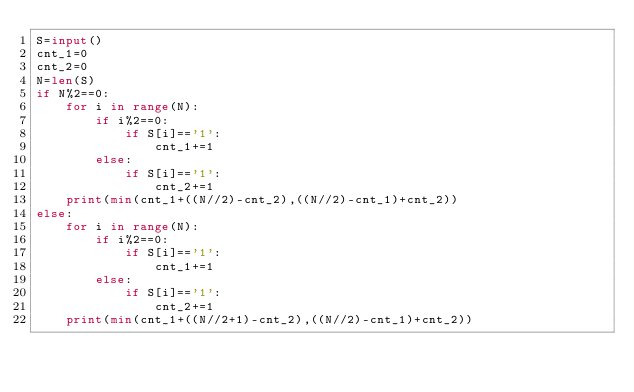Convert code to text. <code><loc_0><loc_0><loc_500><loc_500><_Python_>S=input()
cnt_1=0
cnt_2=0
N=len(S)
if N%2==0:
	for i in range(N):
		if i%2==0:
			if S[i]=='1':
				cnt_1+=1
		else:
			if S[i]=='1':
				cnt_2+=1
	print(min(cnt_1+((N//2)-cnt_2),((N//2)-cnt_1)+cnt_2))
else:
	for i in range(N):
		if i%2==0:
			if S[i]=='1':
				cnt_1+=1
		else:
			if S[i]=='1':
				cnt_2+=1
	print(min(cnt_1+((N//2+1)-cnt_2),((N//2)-cnt_1)+cnt_2))
</code> 